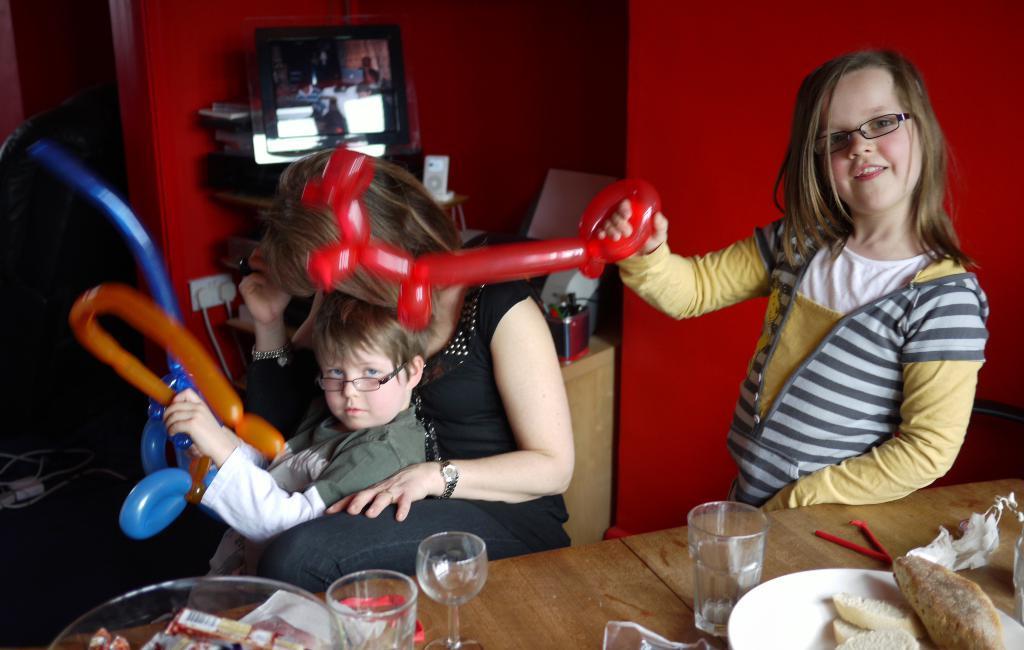Describe this image in one or two sentences. This is the woman sitting. I can see a girl and a boy standing and holding the toy balloons in their hands. This is the table with the glasses, plate, bowls and few other things on it. I can see a monitor, speaker and few other things placed on the table. Here is the wall, which is red in color. On the left side of the image, that looks like a cable. 